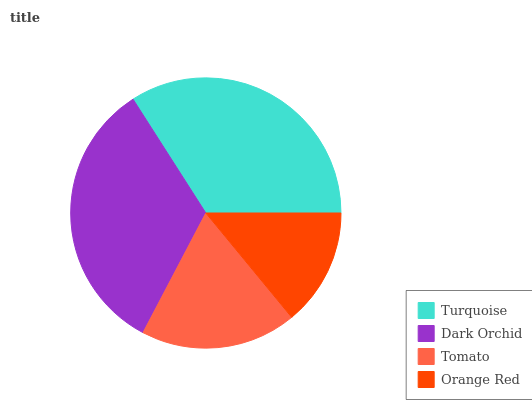Is Orange Red the minimum?
Answer yes or no. Yes. Is Turquoise the maximum?
Answer yes or no. Yes. Is Dark Orchid the minimum?
Answer yes or no. No. Is Dark Orchid the maximum?
Answer yes or no. No. Is Turquoise greater than Dark Orchid?
Answer yes or no. Yes. Is Dark Orchid less than Turquoise?
Answer yes or no. Yes. Is Dark Orchid greater than Turquoise?
Answer yes or no. No. Is Turquoise less than Dark Orchid?
Answer yes or no. No. Is Dark Orchid the high median?
Answer yes or no. Yes. Is Tomato the low median?
Answer yes or no. Yes. Is Turquoise the high median?
Answer yes or no. No. Is Dark Orchid the low median?
Answer yes or no. No. 